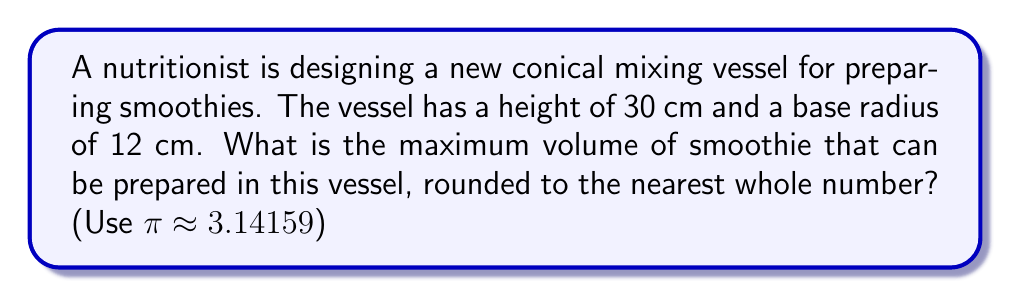Show me your answer to this math problem. To solve this problem, we need to use the formula for the volume of a cone:

$$V = \frac{1}{3}\pi r^2 h$$

Where:
$V$ = volume of the cone
$r$ = radius of the base
$h$ = height of the cone

Given:
$r = 12$ cm
$h = 30$ cm
$\pi \approx 3.14159$

Let's substitute these values into the formula:

$$\begin{align*}
V &= \frac{1}{3}\pi r^2 h \\
&= \frac{1}{3} \times 3.14159 \times 12^2 \times 30 \\
&= \frac{1}{3} \times 3.14159 \times 144 \times 30 \\
&= 4524.6896 \text{ cm}^3
\end{align*}$$

Rounding to the nearest whole number:

$V \approx 4525 \text{ cm}^3$

To convert this to liters, we can use the conversion factor: 1000 cm³ = 1 L

$$4525 \text{ cm}^3 \times \frac{1 \text{ L}}{1000 \text{ cm}^3} = 4.525 \text{ L}$$

[asy]
import geometry;

size(200);

pair A = (0,0), B = (4,0), C = (2,5);
draw(A--B--C--A);
draw((-0.5,0)--(4.5,0));

label("30 cm", (2,2.5), E);
label("12 cm", (2,-0.3), S);

dot("A", A, SW);
dot("B", B, SE);
dot("C", C, N);
[/asy]
Answer: The maximum volume of smoothie that can be prepared in this conical mixing vessel is approximately 4525 cm³ or 4.525 L. 